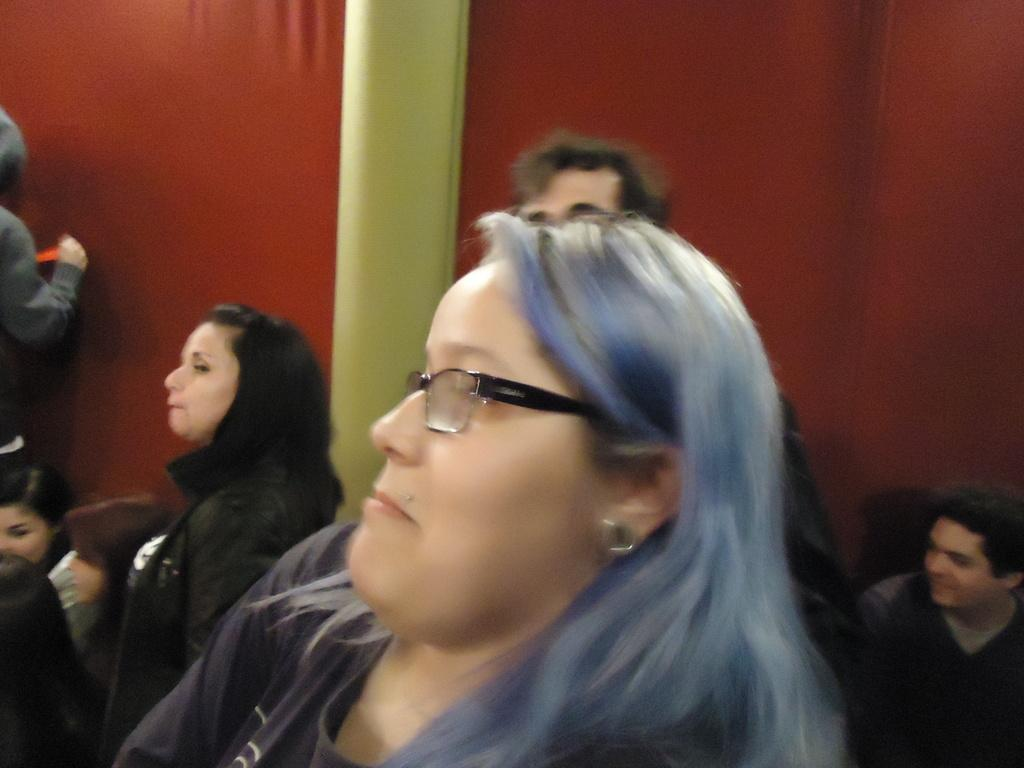What is the main subject of the image? The main subject of the image is a group of people. How can you describe the appearance of the people in the group? The people are wearing different color dresses. Can you identify any specific accessory worn by one of the people in the group? One person in the group is wearing specs. What color cloth can be seen in the background of the image? There is a red color cloth visible in the background of the image. What type of machine is visible in the image? There is no machine present in the image; it features a group of people wearing different color dresses. Can you describe the structure of the cactus in the image? There is no cactus present in the image. 